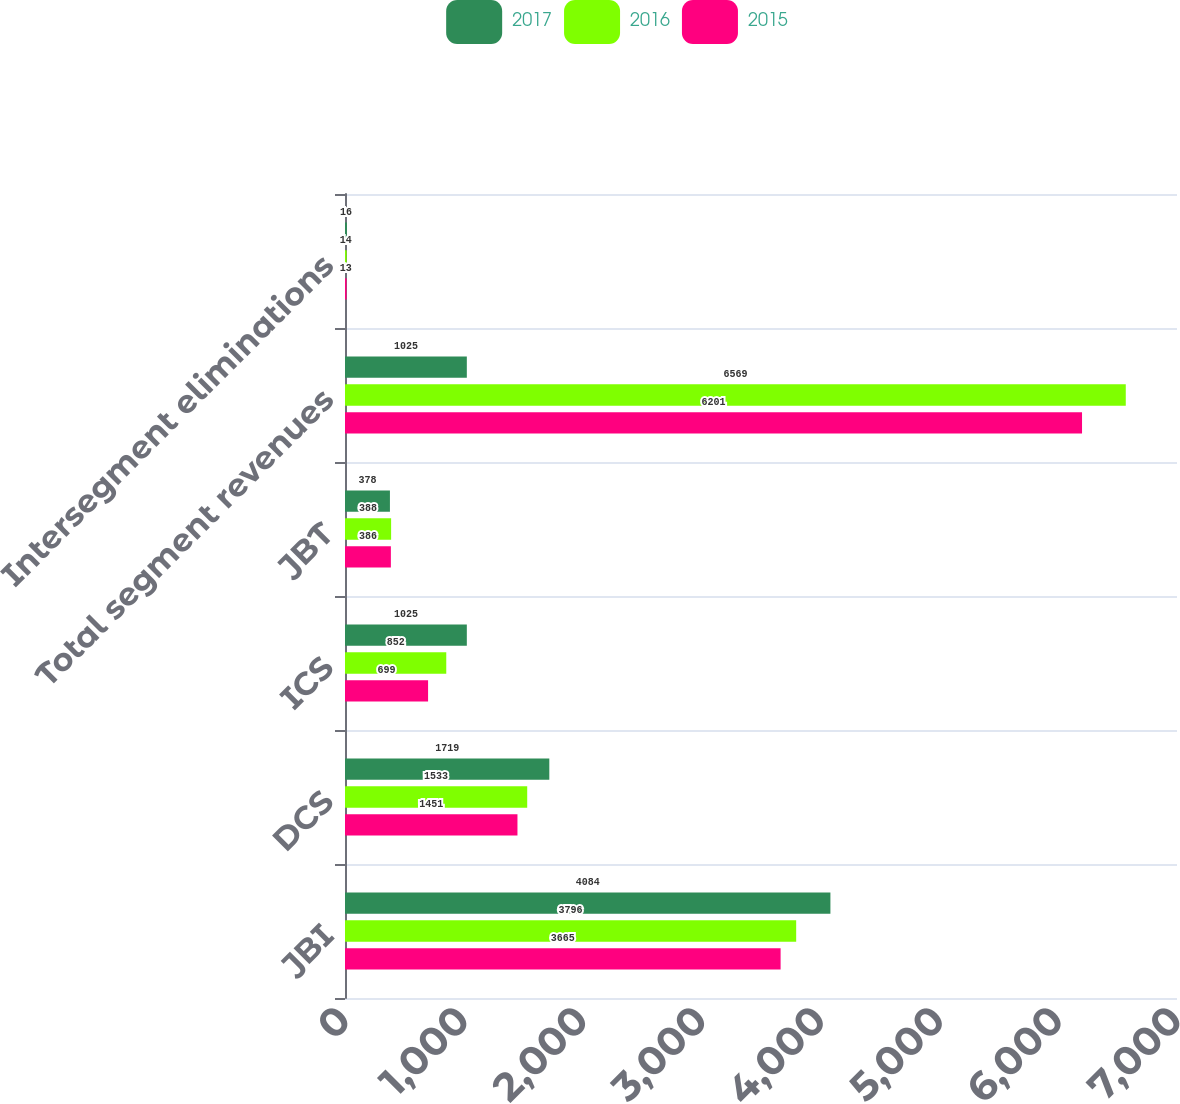Convert chart to OTSL. <chart><loc_0><loc_0><loc_500><loc_500><stacked_bar_chart><ecel><fcel>JBI<fcel>DCS<fcel>ICS<fcel>JBT<fcel>Total segment revenues<fcel>Intersegment eliminations<nl><fcel>2017<fcel>4084<fcel>1719<fcel>1025<fcel>378<fcel>1025<fcel>16<nl><fcel>2016<fcel>3796<fcel>1533<fcel>852<fcel>388<fcel>6569<fcel>14<nl><fcel>2015<fcel>3665<fcel>1451<fcel>699<fcel>386<fcel>6201<fcel>13<nl></chart> 